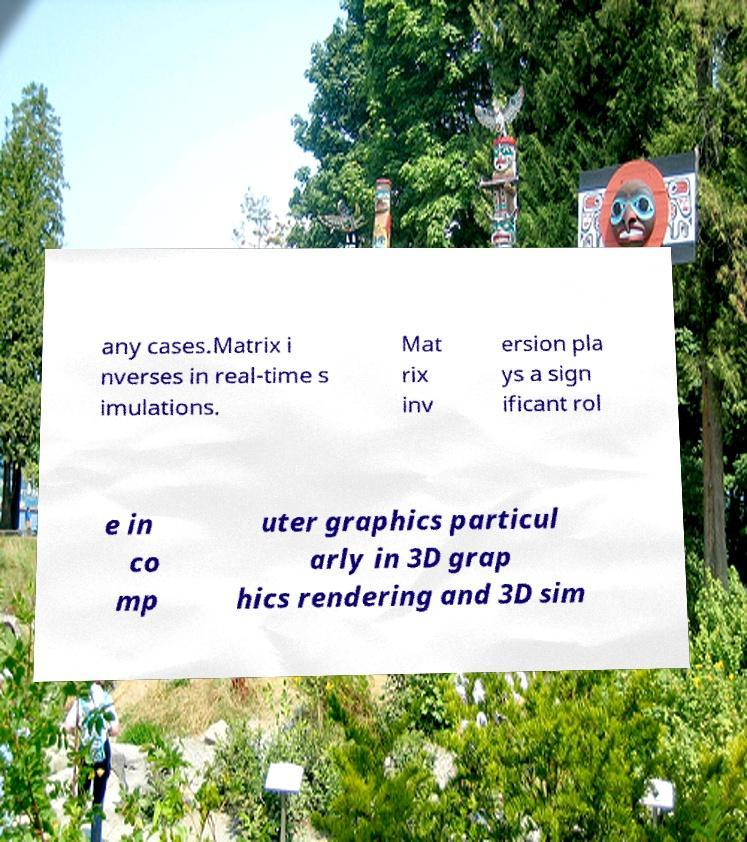Please identify and transcribe the text found in this image. any cases.Matrix i nverses in real-time s imulations. Mat rix inv ersion pla ys a sign ificant rol e in co mp uter graphics particul arly in 3D grap hics rendering and 3D sim 